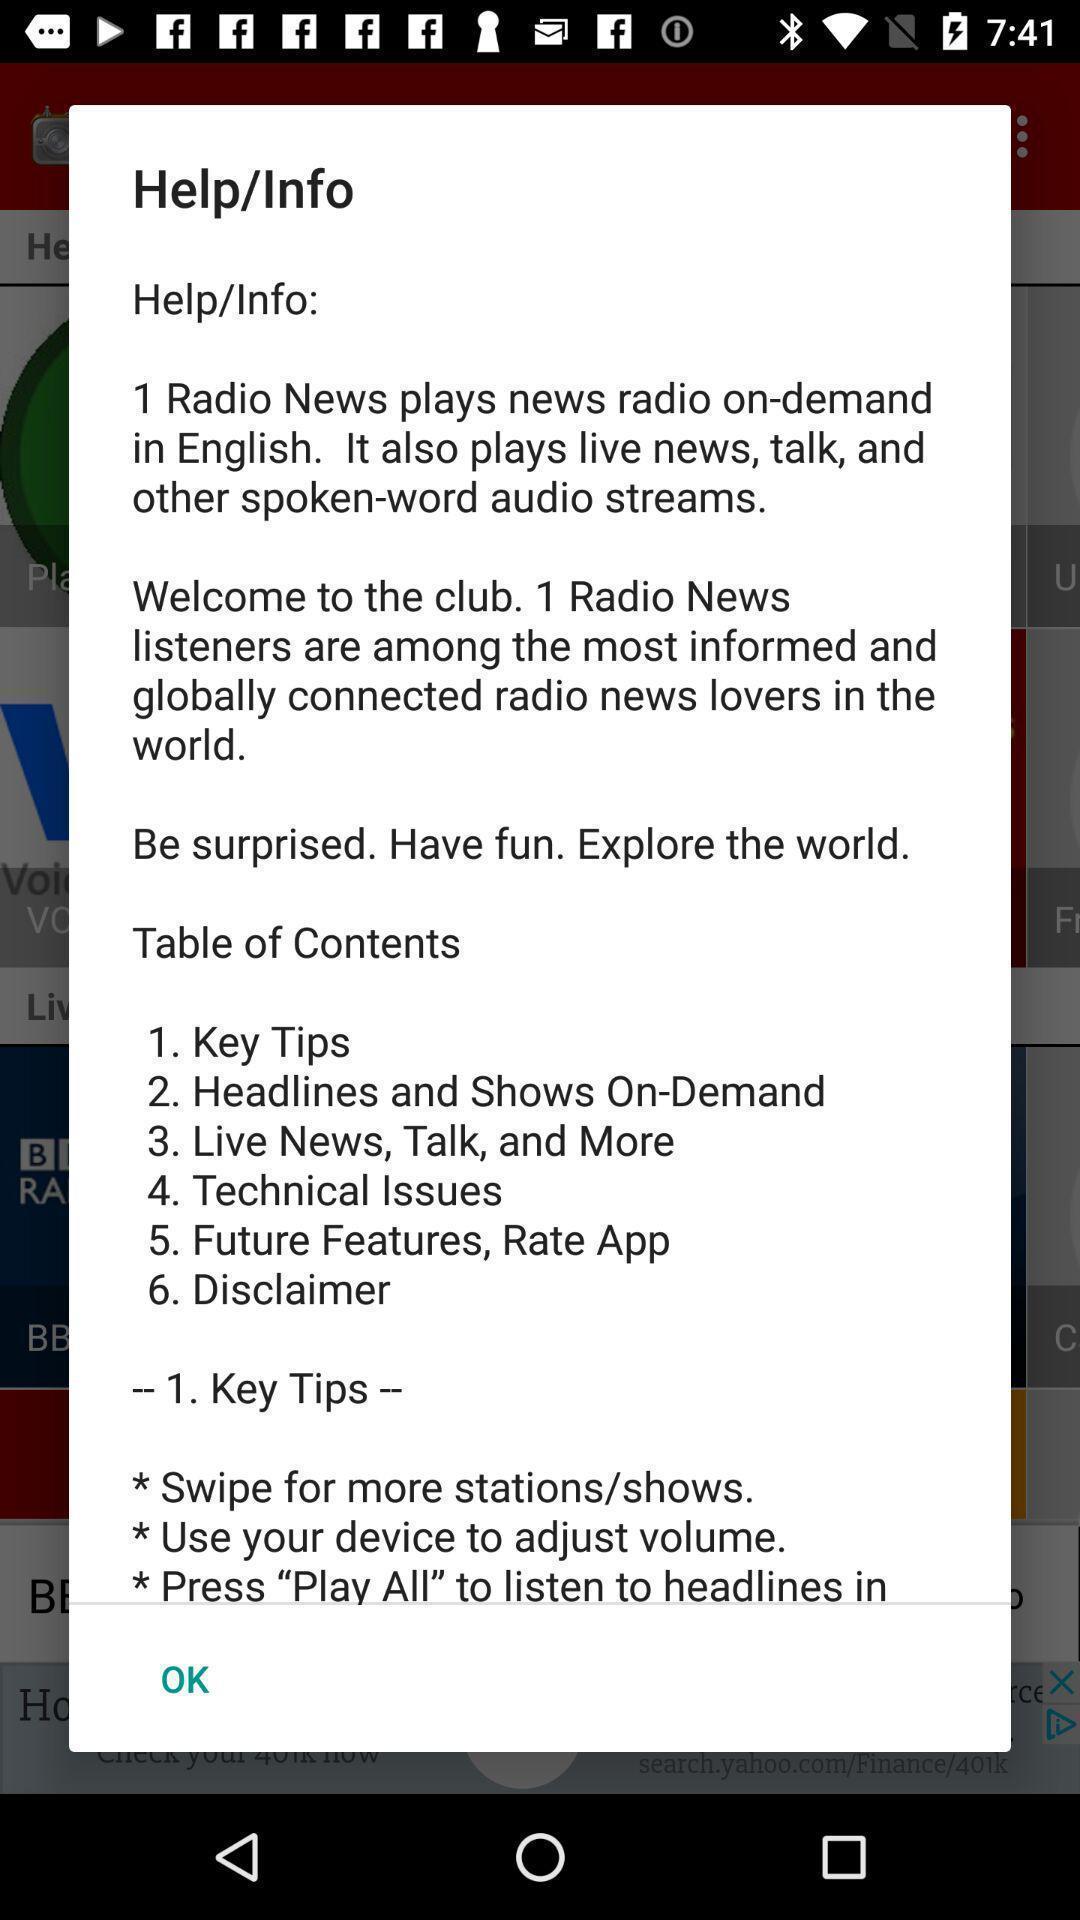Explain what's happening in this screen capture. Pop-up showing the info about an app. 